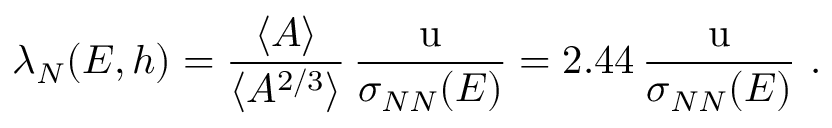<formula> <loc_0><loc_0><loc_500><loc_500>\lambda _ { N } ( E , h ) = { \frac { \langle A \rangle } { \langle A ^ { 2 / 3 } \rangle } } \, { \frac { u } { \sigma _ { N N } ( E ) } } = 2 . 4 4 \, { \frac { u } { \sigma _ { N N } ( E ) } } .</formula> 